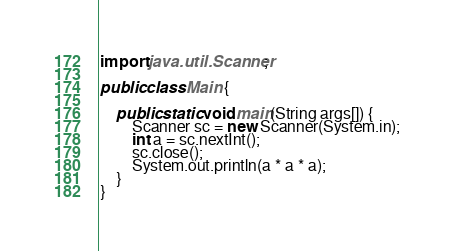<code> <loc_0><loc_0><loc_500><loc_500><_Java_>import java.util.Scanner;

public class Main {

	public static void main(String args[]) {
		Scanner sc = new Scanner(System.in);
		int a = sc.nextInt();
		sc.close();
		System.out.println(a * a * a);
	}
}
</code> 